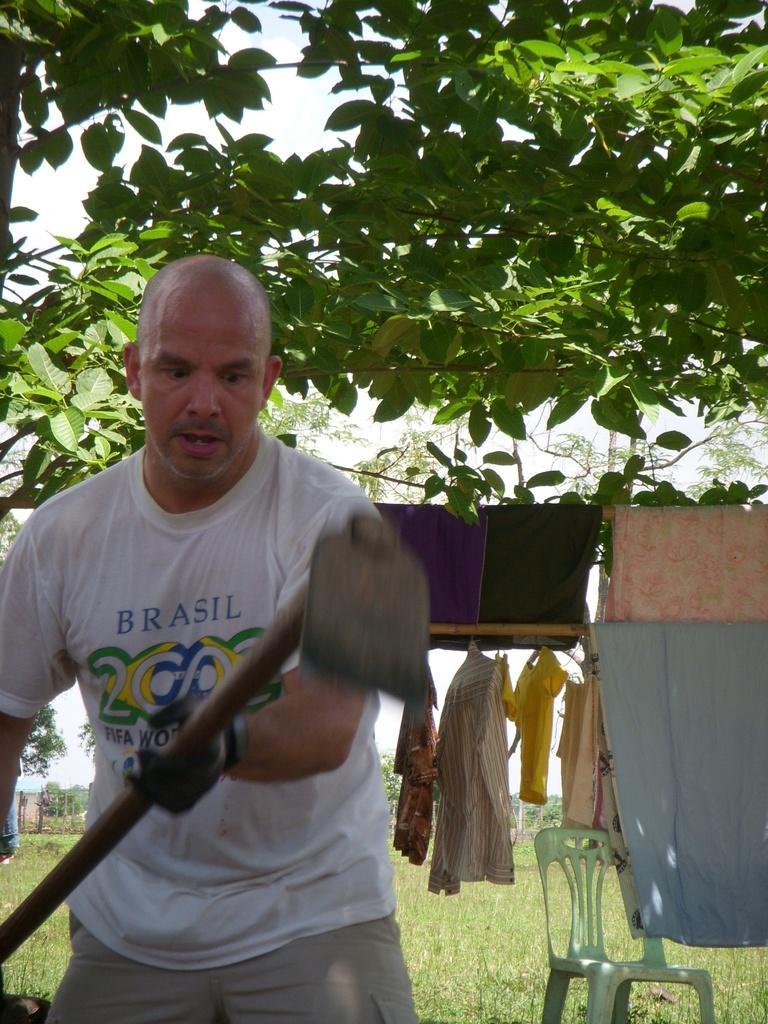Please provide a concise description of this image. In the image we can see there is a man who is standing and he is holding an axe in his hand and at the back there are trees and clothes are hanging to the hanger. 